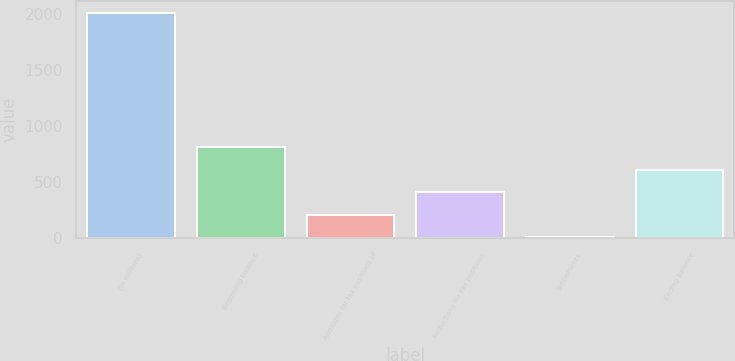Convert chart to OTSL. <chart><loc_0><loc_0><loc_500><loc_500><bar_chart><fcel>(In millions)<fcel>Beginning balance<fcel>Additions for tax positions of<fcel>Reductions for tax positions<fcel>Settlements<fcel>Ending balance<nl><fcel>2014<fcel>811<fcel>209.5<fcel>410<fcel>9<fcel>610.5<nl></chart> 